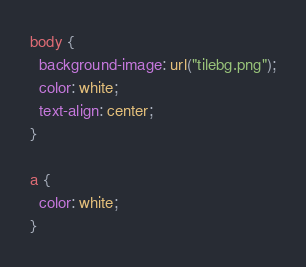<code> <loc_0><loc_0><loc_500><loc_500><_CSS_>body {
  background-image: url("tilebg.png");
  color: white;
  text-align: center;
}

a {
  color: white;
}
</code> 